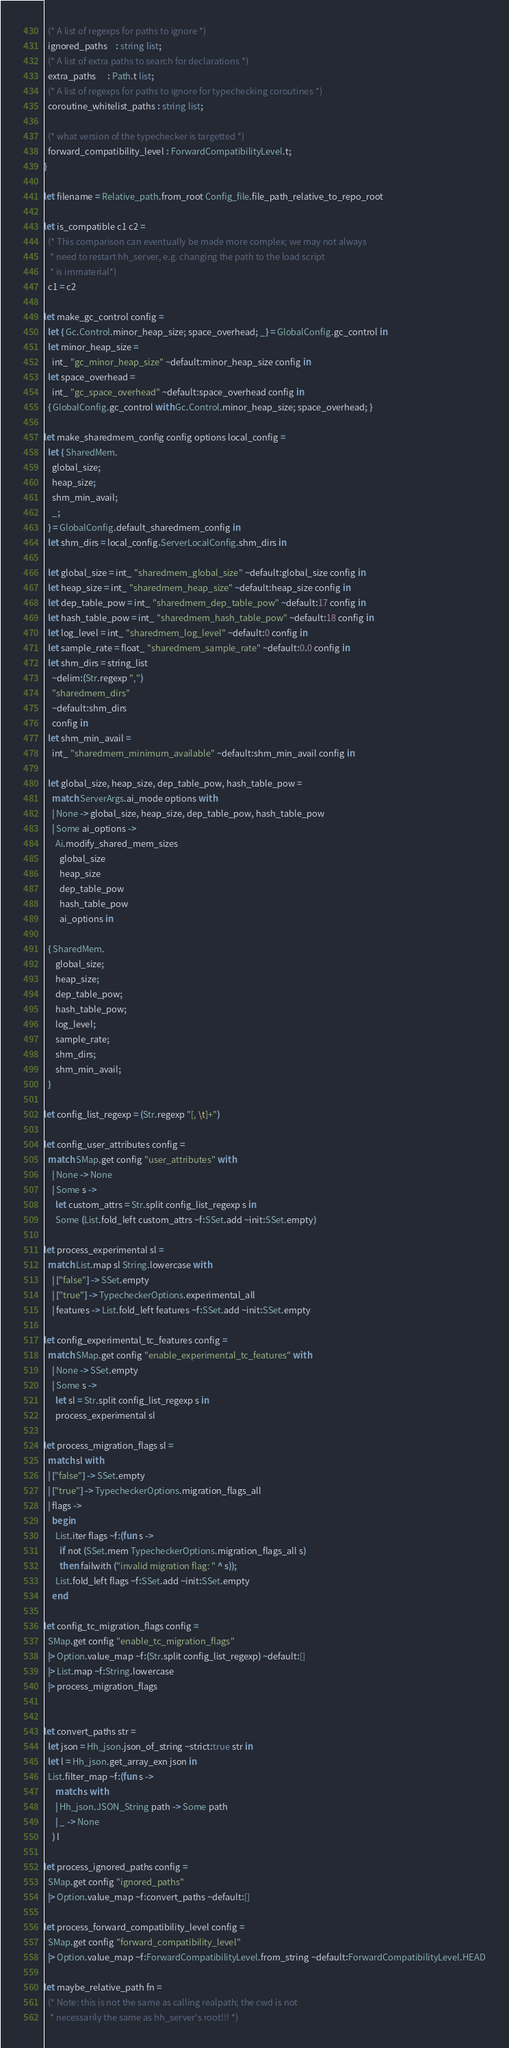Convert code to text. <code><loc_0><loc_0><loc_500><loc_500><_OCaml_>  (* A list of regexps for paths to ignore *)
  ignored_paths    : string list;
  (* A list of extra paths to search for declarations *)
  extra_paths      : Path.t list;
  (* A list of regexps for paths to ignore for typechecking coroutines *)
  coroutine_whitelist_paths : string list;

  (* what version of the typechecker is targetted *)
  forward_compatibility_level : ForwardCompatibilityLevel.t;
}

let filename = Relative_path.from_root Config_file.file_path_relative_to_repo_root

let is_compatible c1 c2 =
  (* This comparison can eventually be made more complex; we may not always
   * need to restart hh_server, e.g. changing the path to the load script
   * is immaterial*)
  c1 = c2

let make_gc_control config =
  let { Gc.Control.minor_heap_size; space_overhead; _} = GlobalConfig.gc_control in
  let minor_heap_size =
    int_ "gc_minor_heap_size" ~default:minor_heap_size config in
  let space_overhead =
    int_ "gc_space_overhead" ~default:space_overhead config in
  { GlobalConfig.gc_control with Gc.Control.minor_heap_size; space_overhead; }

let make_sharedmem_config config options local_config =
  let { SharedMem.
    global_size;
    heap_size;
    shm_min_avail;
    _;
  } = GlobalConfig.default_sharedmem_config in
  let shm_dirs = local_config.ServerLocalConfig.shm_dirs in

  let global_size = int_ "sharedmem_global_size" ~default:global_size config in
  let heap_size = int_ "sharedmem_heap_size" ~default:heap_size config in
  let dep_table_pow = int_ "sharedmem_dep_table_pow" ~default:17 config in
  let hash_table_pow = int_ "sharedmem_hash_table_pow" ~default:18 config in
  let log_level = int_ "sharedmem_log_level" ~default:0 config in
  let sample_rate = float_ "sharedmem_sample_rate" ~default:0.0 config in
  let shm_dirs = string_list
    ~delim:(Str.regexp ",")
    "sharedmem_dirs"
    ~default:shm_dirs
    config in
  let shm_min_avail =
    int_ "sharedmem_minimum_available" ~default:shm_min_avail config in

  let global_size, heap_size, dep_table_pow, hash_table_pow =
    match ServerArgs.ai_mode options with
    | None -> global_size, heap_size, dep_table_pow, hash_table_pow
    | Some ai_options ->
      Ai.modify_shared_mem_sizes
        global_size
        heap_size
        dep_table_pow
        hash_table_pow
        ai_options in

  { SharedMem.
      global_size;
      heap_size;
      dep_table_pow;
      hash_table_pow;
      log_level;
      sample_rate;
      shm_dirs;
      shm_min_avail;
  }

let config_list_regexp = (Str.regexp "[, \t]+")

let config_user_attributes config =
  match SMap.get config "user_attributes" with
    | None -> None
    | Some s ->
      let custom_attrs = Str.split config_list_regexp s in
      Some (List.fold_left custom_attrs ~f:SSet.add ~init:SSet.empty)

let process_experimental sl =
  match List.map sl String.lowercase with
    | ["false"] -> SSet.empty
    | ["true"] -> TypecheckerOptions.experimental_all
    | features -> List.fold_left features ~f:SSet.add ~init:SSet.empty

let config_experimental_tc_features config =
  match SMap.get config "enable_experimental_tc_features" with
    | None -> SSet.empty
    | Some s ->
      let sl = Str.split config_list_regexp s in
      process_experimental sl

let process_migration_flags sl =
  match sl with
  | ["false"] -> SSet.empty
  | ["true"] -> TypecheckerOptions.migration_flags_all
  | flags ->
    begin
      List.iter flags ~f:(fun s ->
        if not (SSet.mem TypecheckerOptions.migration_flags_all s)
        then failwith ("invalid migration flag: " ^ s));
      List.fold_left flags ~f:SSet.add ~init:SSet.empty
    end

let config_tc_migration_flags config =
  SMap.get config "enable_tc_migration_flags"
  |> Option.value_map ~f:(Str.split config_list_regexp) ~default:[]
  |> List.map ~f:String.lowercase
  |> process_migration_flags


let convert_paths str =
  let json = Hh_json.json_of_string ~strict:true str in
  let l = Hh_json.get_array_exn json in
  List.filter_map ~f:(fun s ->
      match s with
      | Hh_json.JSON_String path -> Some path
      | _ -> None
    ) l

let process_ignored_paths config =
  SMap.get config "ignored_paths"
  |> Option.value_map ~f:convert_paths ~default:[]

let process_forward_compatibility_level config =
  SMap.get config "forward_compatibility_level"
  |> Option.value_map ~f:ForwardCompatibilityLevel.from_string ~default:ForwardCompatibilityLevel.HEAD

let maybe_relative_path fn =
  (* Note: this is not the same as calling realpath; the cwd is not
   * necessarily the same as hh_server's root!!! *)</code> 